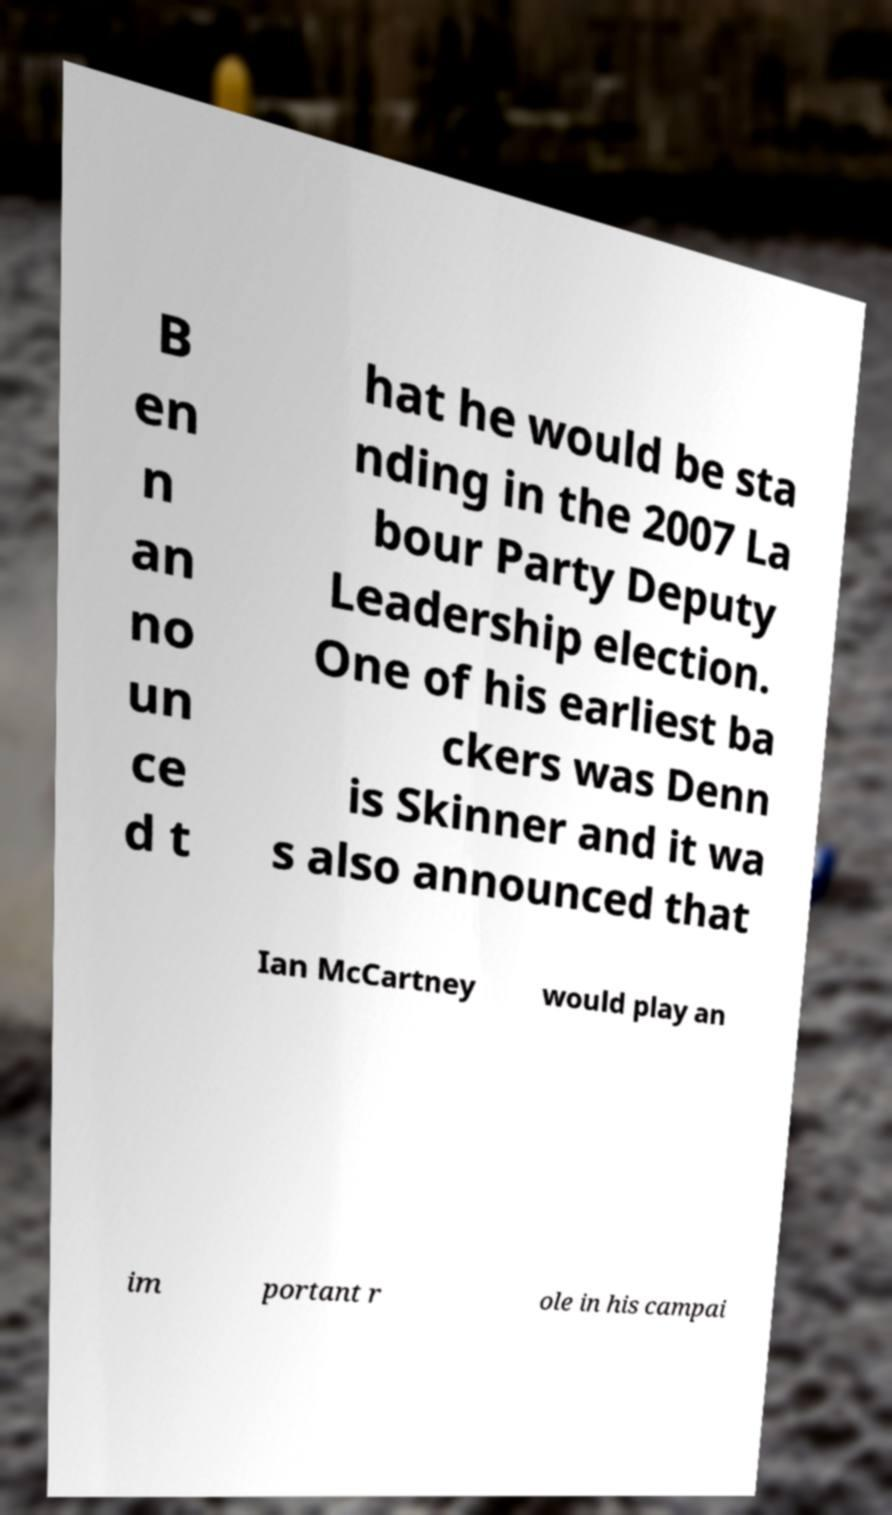I need the written content from this picture converted into text. Can you do that? B en n an no un ce d t hat he would be sta nding in the 2007 La bour Party Deputy Leadership election. One of his earliest ba ckers was Denn is Skinner and it wa s also announced that Ian McCartney would play an im portant r ole in his campai 